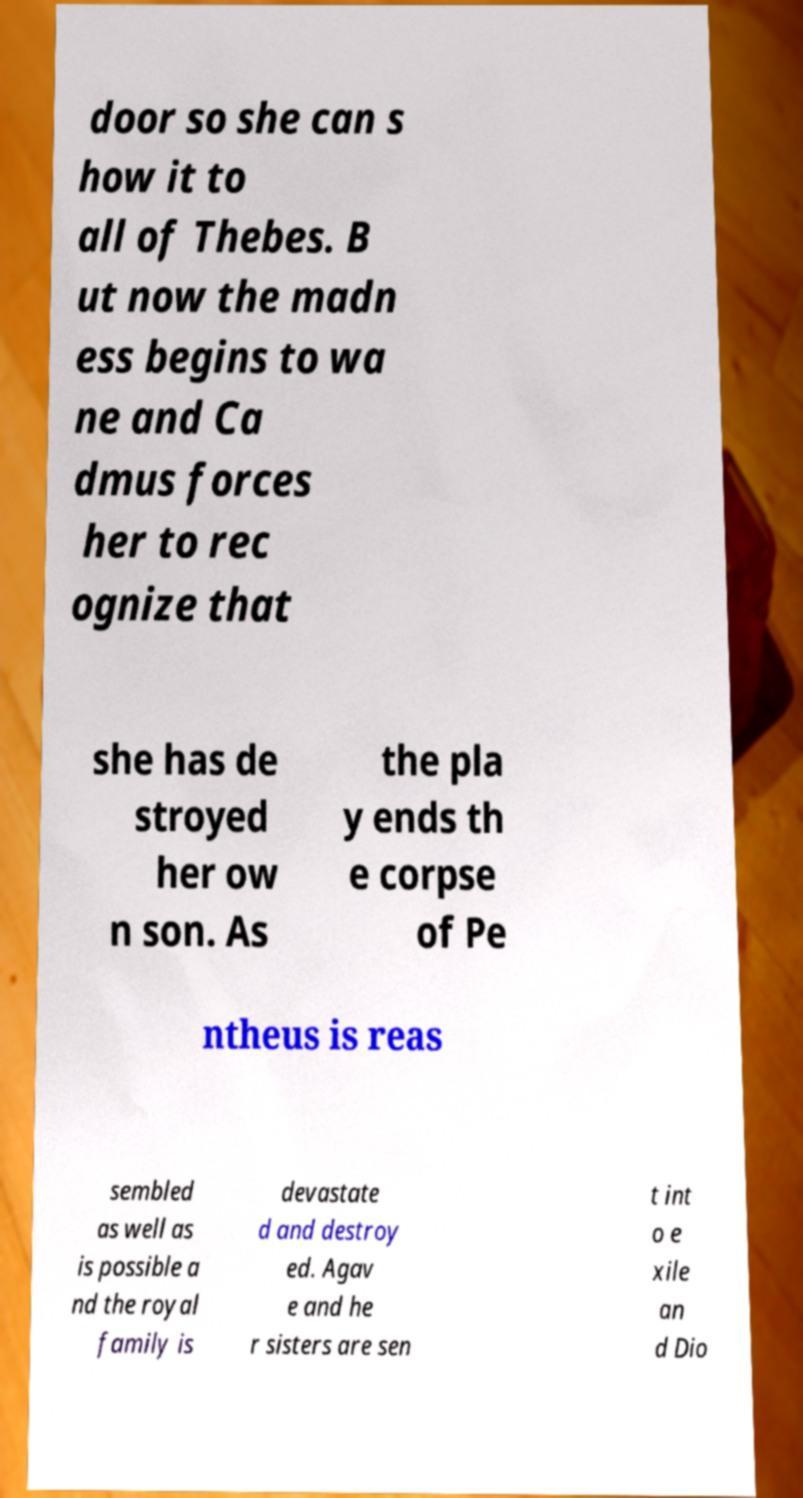Could you extract and type out the text from this image? door so she can s how it to all of Thebes. B ut now the madn ess begins to wa ne and Ca dmus forces her to rec ognize that she has de stroyed her ow n son. As the pla y ends th e corpse of Pe ntheus is reas sembled as well as is possible a nd the royal family is devastate d and destroy ed. Agav e and he r sisters are sen t int o e xile an d Dio 